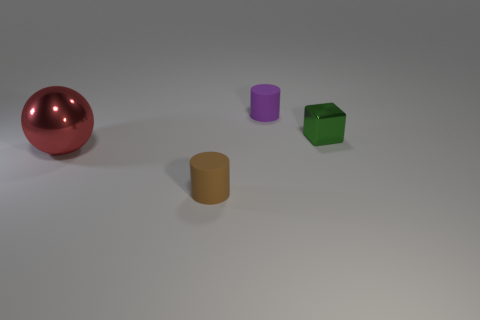Add 1 small purple metal blocks. How many objects exist? 5 Subtract all cubes. How many objects are left? 3 Add 4 blocks. How many blocks exist? 5 Subtract 0 cyan cubes. How many objects are left? 4 Subtract all green metal things. Subtract all objects. How many objects are left? 2 Add 4 big red metal things. How many big red metal things are left? 5 